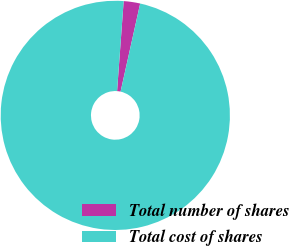Convert chart. <chart><loc_0><loc_0><loc_500><loc_500><pie_chart><fcel>Total number of shares<fcel>Total cost of shares<nl><fcel>2.32%<fcel>97.68%<nl></chart> 